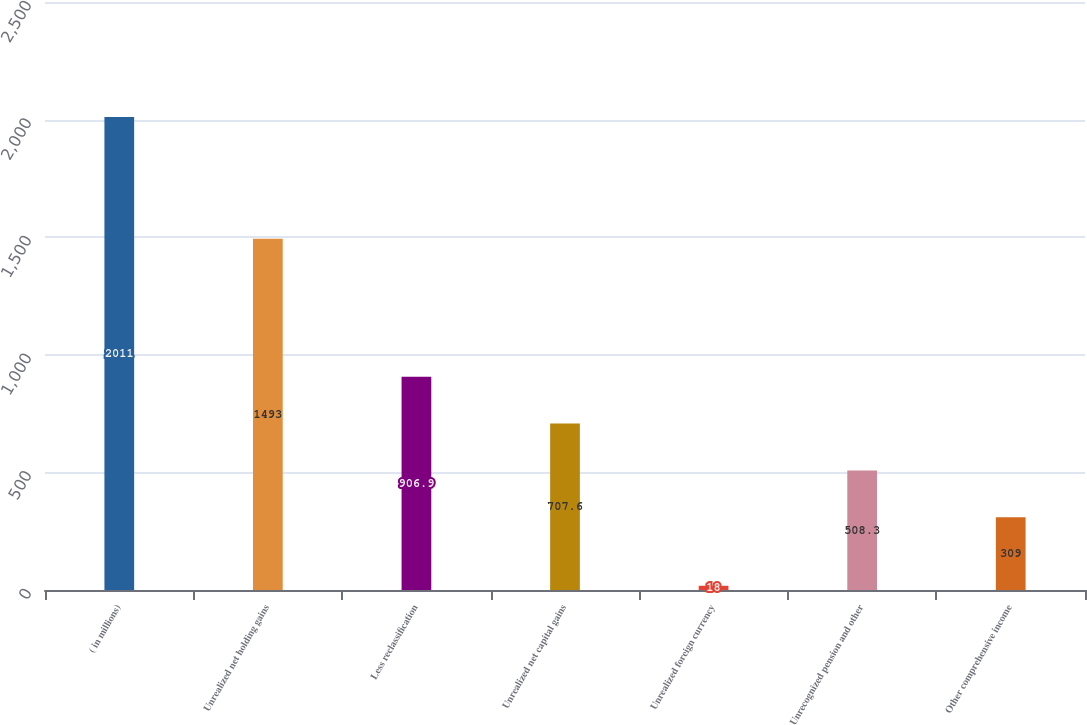Convert chart. <chart><loc_0><loc_0><loc_500><loc_500><bar_chart><fcel>( in millions)<fcel>Unrealized net holding gains<fcel>Less reclassification<fcel>Unrealized net capital gains<fcel>Unrealized foreign currency<fcel>Unrecognized pension and other<fcel>Other comprehensive income<nl><fcel>2011<fcel>1493<fcel>906.9<fcel>707.6<fcel>18<fcel>508.3<fcel>309<nl></chart> 